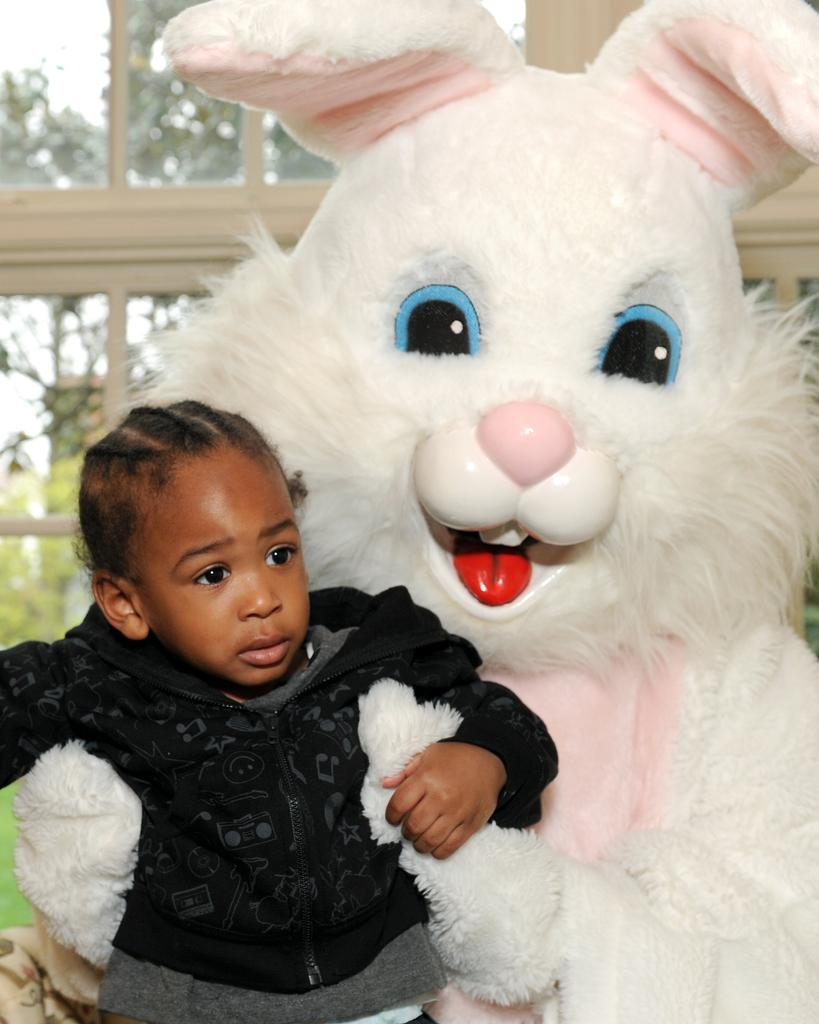What is located in the front of the image? There is a toy and a boy in the front of the image. Can you describe the toy in the image? The toy is not described in the facts provided, so we cannot provide a detailed description. What is visible in the background of the image? There are glass windows in the background of the image. What can be seen through the glass windows? Trees are visible through the glass windows. Where is the crib located in the image? There is no crib present in the image. What type of stove is visible in the image? There is no stove present in the image. 